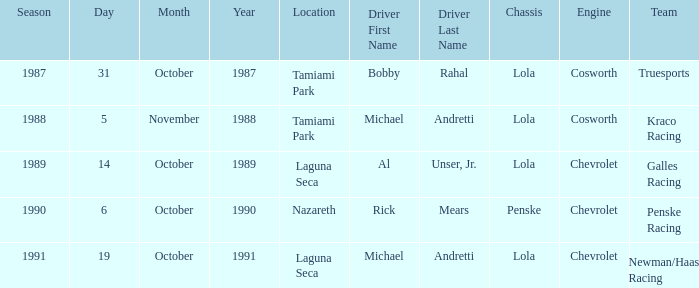On what date was the race at Nazareth? October 6. 